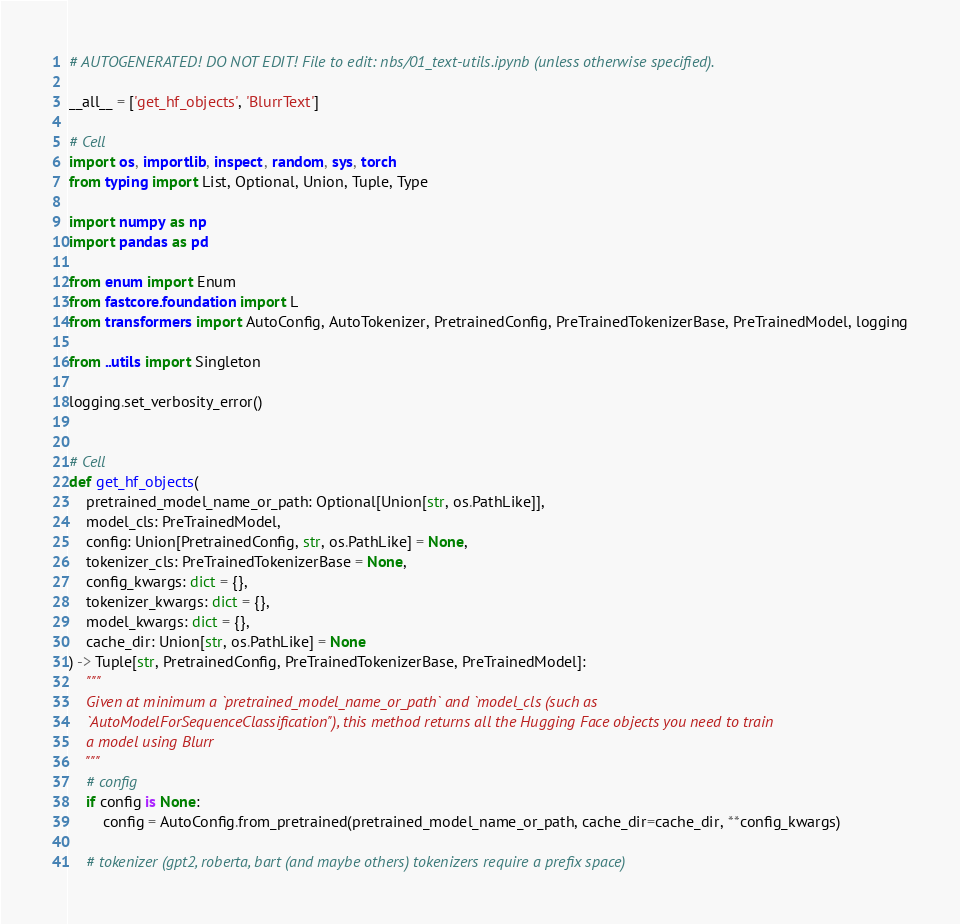Convert code to text. <code><loc_0><loc_0><loc_500><loc_500><_Python_># AUTOGENERATED! DO NOT EDIT! File to edit: nbs/01_text-utils.ipynb (unless otherwise specified).

__all__ = ['get_hf_objects', 'BlurrText']

# Cell
import os, importlib, inspect, random, sys, torch
from typing import List, Optional, Union, Tuple, Type

import numpy as np
import pandas as pd

from enum import Enum
from fastcore.foundation import L
from transformers import AutoConfig, AutoTokenizer, PretrainedConfig, PreTrainedTokenizerBase, PreTrainedModel, logging

from ..utils import Singleton

logging.set_verbosity_error()


# Cell
def get_hf_objects(
    pretrained_model_name_or_path: Optional[Union[str, os.PathLike]],
    model_cls: PreTrainedModel,
    config: Union[PretrainedConfig, str, os.PathLike] = None,
    tokenizer_cls: PreTrainedTokenizerBase = None,
    config_kwargs: dict = {},
    tokenizer_kwargs: dict = {},
    model_kwargs: dict = {},
    cache_dir: Union[str, os.PathLike] = None
) -> Tuple[str, PretrainedConfig, PreTrainedTokenizerBase, PreTrainedModel]:
    """
    Given at minimum a `pretrained_model_name_or_path` and `model_cls (such as
    `AutoModelForSequenceClassification"), this method returns all the Hugging Face objects you need to train
    a model using Blurr
    """
    # config
    if config is None:
        config = AutoConfig.from_pretrained(pretrained_model_name_or_path, cache_dir=cache_dir, **config_kwargs)

    # tokenizer (gpt2, roberta, bart (and maybe others) tokenizers require a prefix space)</code> 